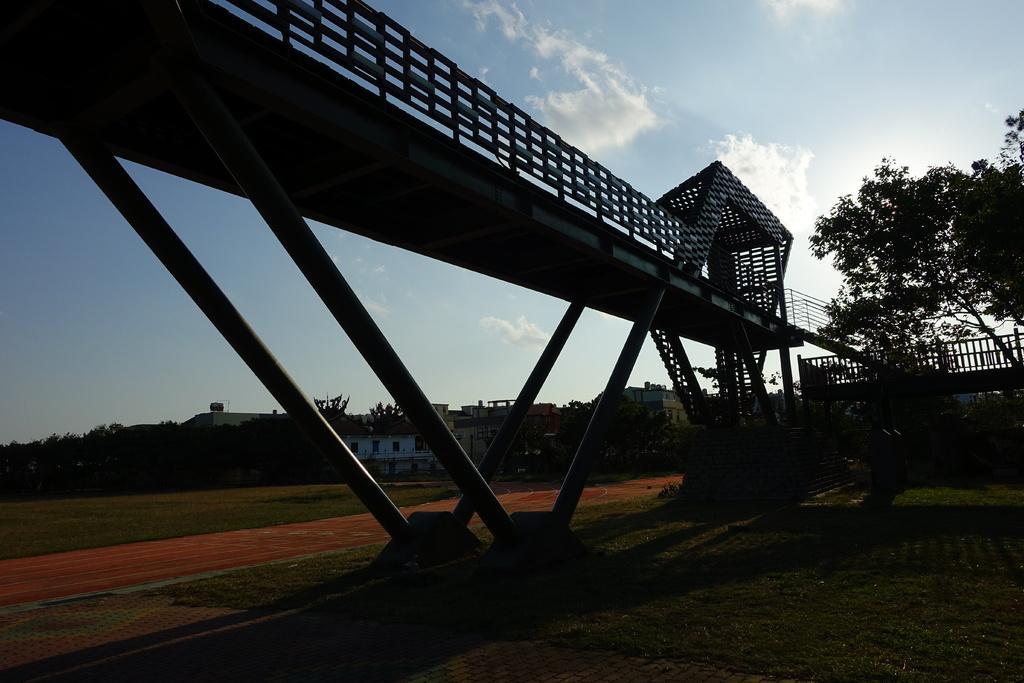How would you summarize this image in a sentence or two? In this image we can see there is a bridge. On the right side of the image there is a tree. In the background of the image there are buildings, trees and the sky. 